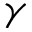Convert formula to latex. <formula><loc_0><loc_0><loc_500><loc_500>\gamma</formula> 